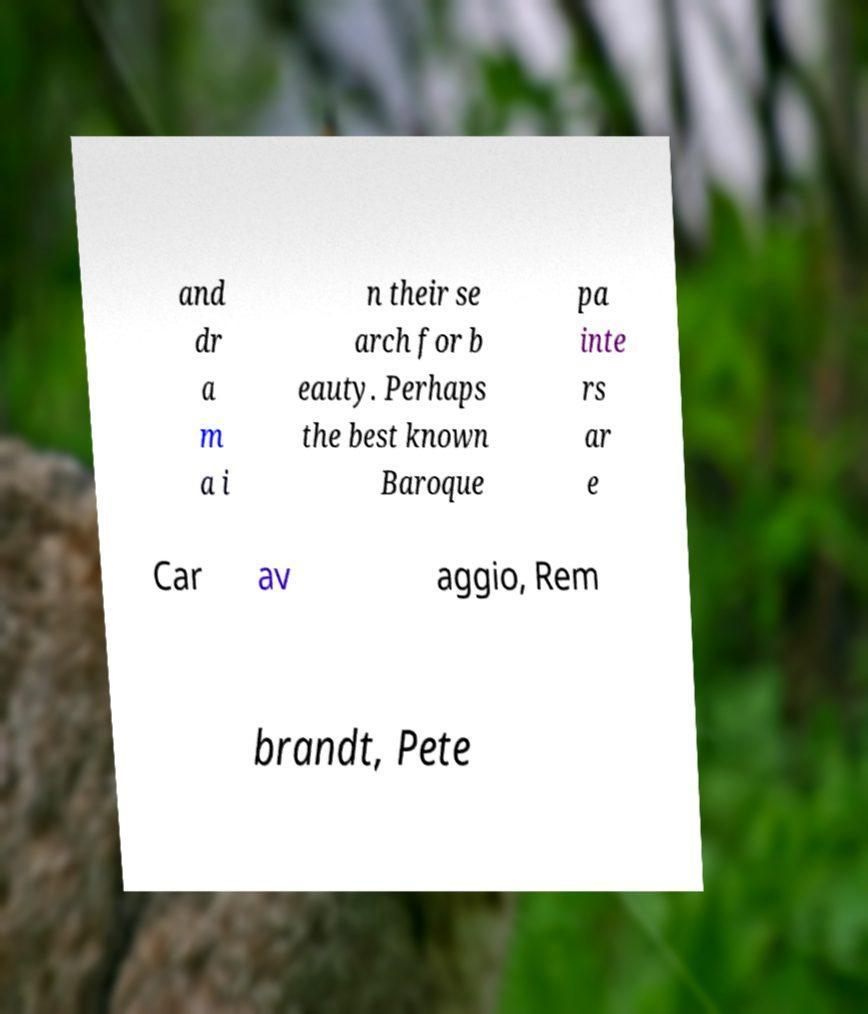What messages or text are displayed in this image? I need them in a readable, typed format. and dr a m a i n their se arch for b eauty. Perhaps the best known Baroque pa inte rs ar e Car av aggio, Rem brandt, Pete 